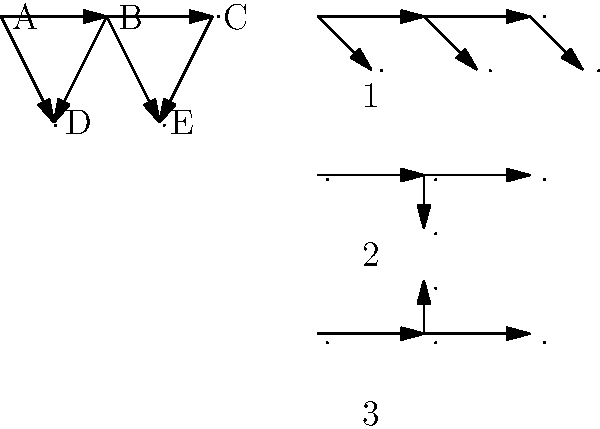Given the unfolded neural network architecture diagram on the left, which of the folded representations (labeled 1, 2, or 3) on the right correctly represents the same network structure? To solve this problem, we need to analyze the unfolded network structure and compare it with the folded options:

1. Analyze the unfolded network:
   - It has 5 nodes (A, B, C, D, E)
   - The connections are: A-B, B-C, A-D, B-D, B-E, C-E

2. Examine the folded options:
   Option 1:
   - Has 5 nodes
   - Maintains all connections from the unfolded network
   - Preserves the linear structure of A-B-C
   - Correctly represents D and E as lower-level nodes

   Option 2:
   - Has 5 nodes
   - Missing the connection between the first and third nodes (A-C)
   - Does not accurately represent the structure

   Option 3:
   - Has 5 nodes
   - Missing connections between the first and third nodes (A-C)
   - The upper node does not accurately represent the network structure

3. Compare and conclude:
   Option 1 is the only representation that correctly maintains all nodes and connections from the unfolded network while preserving the overall structure.
Answer: 1 